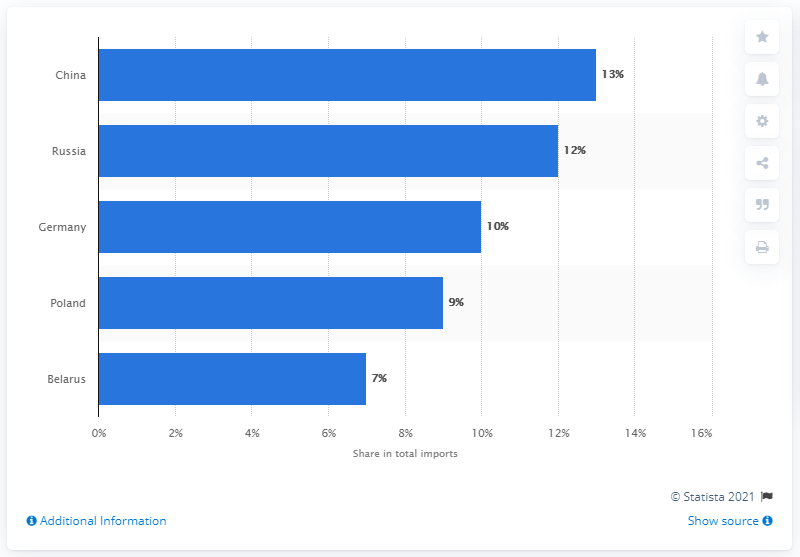Specify some key components in this picture. In 2019, Ukraine's main import partner was China. 